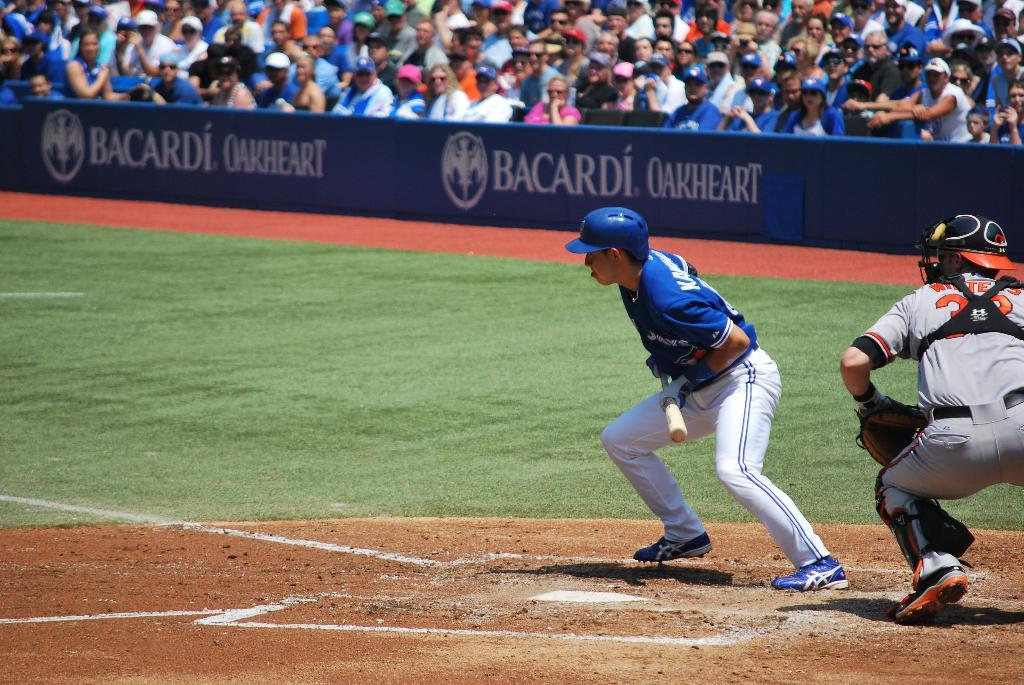<image>
Provide a brief description of the given image. A few baseball players waiting to bat with Bacardi as a sponser 